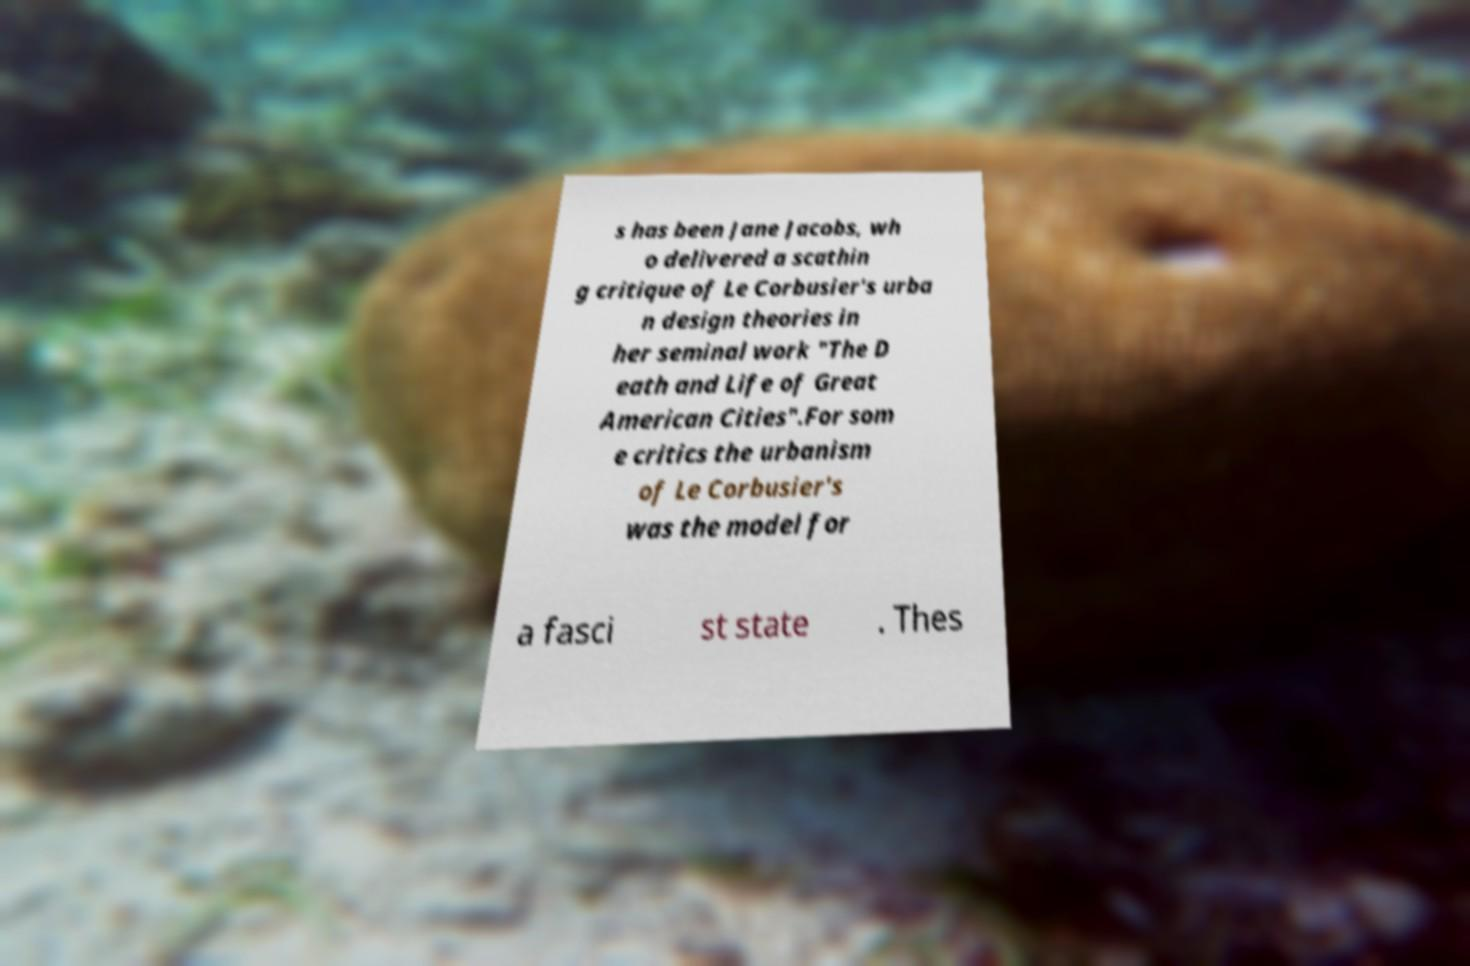What messages or text are displayed in this image? I need them in a readable, typed format. s has been Jane Jacobs, wh o delivered a scathin g critique of Le Corbusier's urba n design theories in her seminal work "The D eath and Life of Great American Cities".For som e critics the urbanism of Le Corbusier's was the model for a fasci st state . Thes 